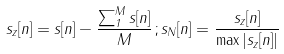Convert formula to latex. <formula><loc_0><loc_0><loc_500><loc_500>s _ { z } [ n ] = s [ n ] - \frac { \sum _ { 1 } ^ { M } s [ n ] } { M } \, ; s _ { N } [ n ] = \frac { s _ { z } [ n ] } { \max | s _ { z } [ n ] | }</formula> 